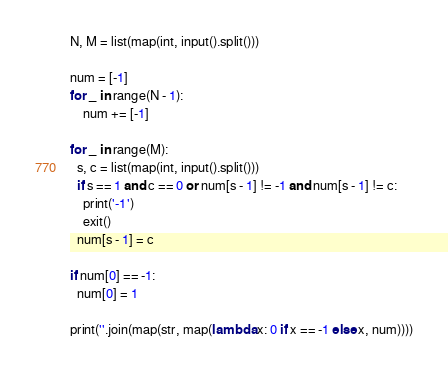<code> <loc_0><loc_0><loc_500><loc_500><_Python_>N, M = list(map(int, input().split()))

num = [-1]
for _ in range(N - 1):
	num += [-1]

for _ in range(M):
  s, c = list(map(int, input().split()))
  if s == 1 and c == 0 or num[s - 1] != -1 and num[s - 1] != c:
    print('-1')
    exit()
  num[s - 1] = c

if num[0] == -1:
  num[0] = 1

print(''.join(map(str, map(lambda x: 0 if x == -1 else x, num))))</code> 